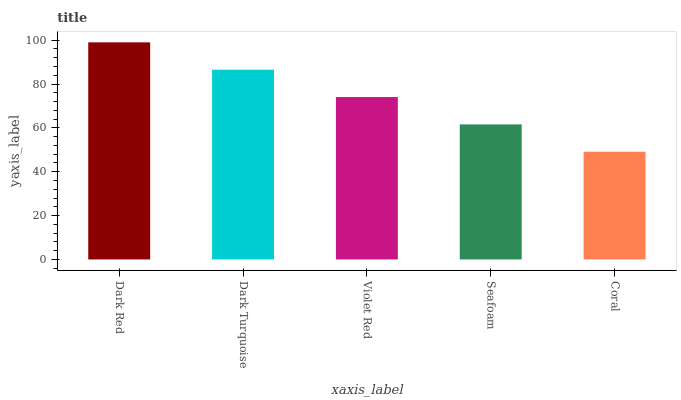Is Dark Turquoise the minimum?
Answer yes or no. No. Is Dark Turquoise the maximum?
Answer yes or no. No. Is Dark Red greater than Dark Turquoise?
Answer yes or no. Yes. Is Dark Turquoise less than Dark Red?
Answer yes or no. Yes. Is Dark Turquoise greater than Dark Red?
Answer yes or no. No. Is Dark Red less than Dark Turquoise?
Answer yes or no. No. Is Violet Red the high median?
Answer yes or no. Yes. Is Violet Red the low median?
Answer yes or no. Yes. Is Coral the high median?
Answer yes or no. No. Is Coral the low median?
Answer yes or no. No. 